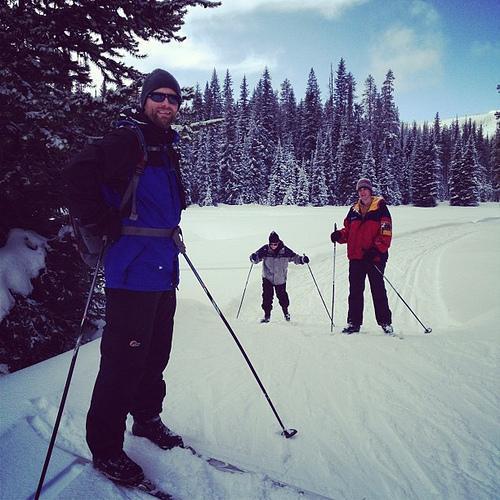How many people are pictured?
Give a very brief answer. 3. 